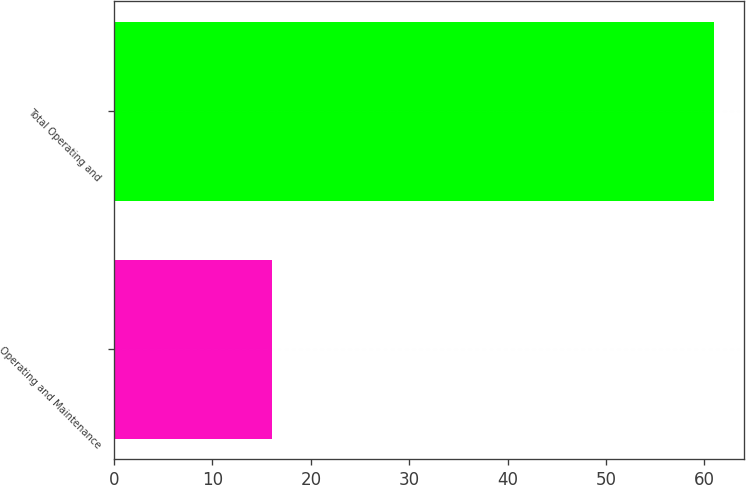<chart> <loc_0><loc_0><loc_500><loc_500><bar_chart><fcel>Operating and Maintenance<fcel>Total Operating and<nl><fcel>16<fcel>61<nl></chart> 